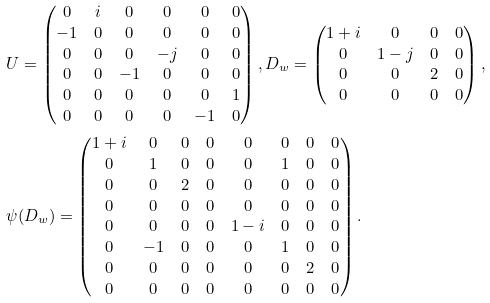Convert formula to latex. <formula><loc_0><loc_0><loc_500><loc_500>& { U } = \begin{pmatrix} 0 & i & 0 & 0 & 0 & 0 \\ - 1 & 0 & 0 & 0 & 0 & 0 \\ 0 & 0 & 0 & - j & 0 & 0 \\ 0 & 0 & - 1 & 0 & 0 & 0 \\ 0 & 0 & 0 & 0 & 0 & 1 \\ 0 & 0 & 0 & 0 & - 1 & 0 \\ \end{pmatrix} , { D } _ { w } = \begin{pmatrix} 1 + i & 0 & 0 & 0 \\ 0 & 1 - j & 0 & 0 \\ 0 & 0 & 2 & 0 \\ 0 & 0 & 0 & 0 \end{pmatrix} , \\ & \psi ( { D } _ { w } ) = \begin{pmatrix} 1 + i & 0 & 0 & 0 & 0 & 0 & 0 & 0 \\ 0 & 1 & 0 & 0 & 0 & 1 & 0 & 0 \\ 0 & 0 & 2 & 0 & 0 & 0 & 0 & 0 \\ 0 & 0 & 0 & 0 & 0 & 0 & 0 & 0 \\ 0 & 0 & 0 & 0 & 1 - i & 0 & 0 & 0 \\ 0 & - 1 & 0 & 0 & 0 & 1 & 0 & 0 \\ 0 & 0 & 0 & 0 & 0 & 0 & 2 & 0 \\ 0 & 0 & 0 & 0 & 0 & 0 & 0 & 0 \end{pmatrix} .</formula> 